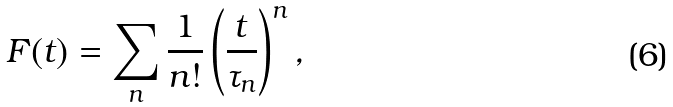Convert formula to latex. <formula><loc_0><loc_0><loc_500><loc_500>F ( t ) = \sum _ { n } \frac { 1 } { n ! } \left ( \frac { t } { \tau _ { n } } \right ) ^ { n } ,</formula> 